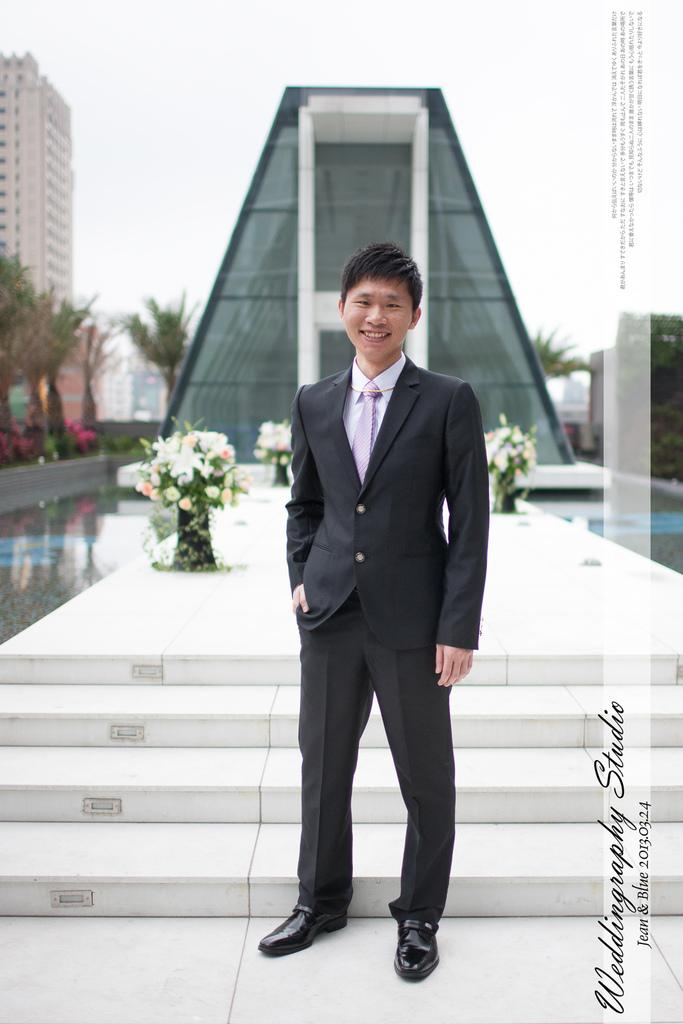Who is present in the image? There is a man in the image. What is the man's facial expression? The man is smiling. What type of vegetation can be seen in the image? There are flowers and trees visible in the image. What type of structures are present in the image? There are buildings in the image. What natural element can be seen in the image? There is water visible in the image. Can you hear the man's voice in the image? The image is a still photograph, so there is no sound or voice present. 